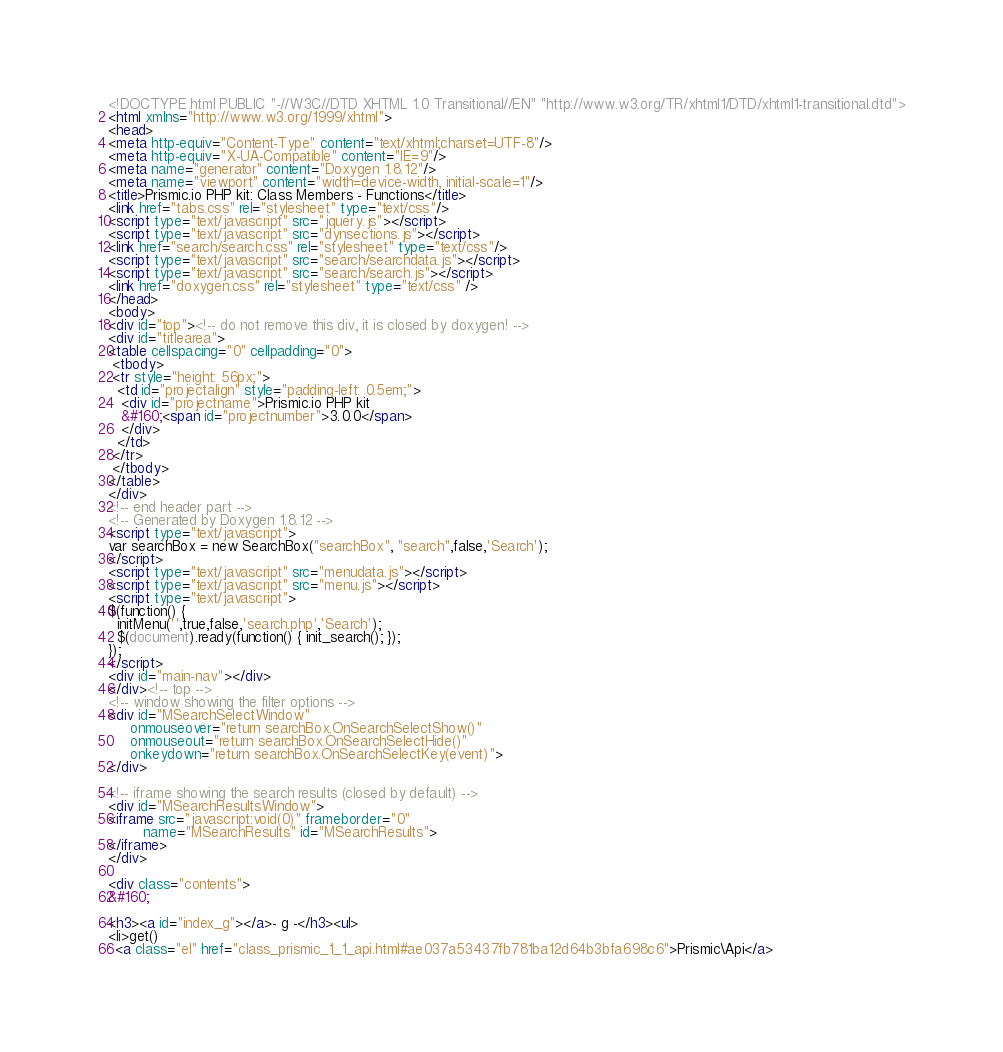Convert code to text. <code><loc_0><loc_0><loc_500><loc_500><_HTML_><!DOCTYPE html PUBLIC "-//W3C//DTD XHTML 1.0 Transitional//EN" "http://www.w3.org/TR/xhtml1/DTD/xhtml1-transitional.dtd">
<html xmlns="http://www.w3.org/1999/xhtml">
<head>
<meta http-equiv="Content-Type" content="text/xhtml;charset=UTF-8"/>
<meta http-equiv="X-UA-Compatible" content="IE=9"/>
<meta name="generator" content="Doxygen 1.8.12"/>
<meta name="viewport" content="width=device-width, initial-scale=1"/>
<title>Prismic.io PHP kit: Class Members - Functions</title>
<link href="tabs.css" rel="stylesheet" type="text/css"/>
<script type="text/javascript" src="jquery.js"></script>
<script type="text/javascript" src="dynsections.js"></script>
<link href="search/search.css" rel="stylesheet" type="text/css"/>
<script type="text/javascript" src="search/searchdata.js"></script>
<script type="text/javascript" src="search/search.js"></script>
<link href="doxygen.css" rel="stylesheet" type="text/css" />
</head>
<body>
<div id="top"><!-- do not remove this div, it is closed by doxygen! -->
<div id="titlearea">
<table cellspacing="0" cellpadding="0">
 <tbody>
 <tr style="height: 56px;">
  <td id="projectalign" style="padding-left: 0.5em;">
   <div id="projectname">Prismic.io PHP kit
   &#160;<span id="projectnumber">3.0.0</span>
   </div>
  </td>
 </tr>
 </tbody>
</table>
</div>
<!-- end header part -->
<!-- Generated by Doxygen 1.8.12 -->
<script type="text/javascript">
var searchBox = new SearchBox("searchBox", "search",false,'Search');
</script>
<script type="text/javascript" src="menudata.js"></script>
<script type="text/javascript" src="menu.js"></script>
<script type="text/javascript">
$(function() {
  initMenu('',true,false,'search.php','Search');
  $(document).ready(function() { init_search(); });
});
</script>
<div id="main-nav"></div>
</div><!-- top -->
<!-- window showing the filter options -->
<div id="MSearchSelectWindow"
     onmouseover="return searchBox.OnSearchSelectShow()"
     onmouseout="return searchBox.OnSearchSelectHide()"
     onkeydown="return searchBox.OnSearchSelectKey(event)">
</div>

<!-- iframe showing the search results (closed by default) -->
<div id="MSearchResultsWindow">
<iframe src="javascript:void(0)" frameborder="0" 
        name="MSearchResults" id="MSearchResults">
</iframe>
</div>

<div class="contents">
&#160;

<h3><a id="index_g"></a>- g -</h3><ul>
<li>get()
: <a class="el" href="class_prismic_1_1_api.html#ae037a53437fb781ba12d64b3bfa698c6">Prismic\Api</a></code> 